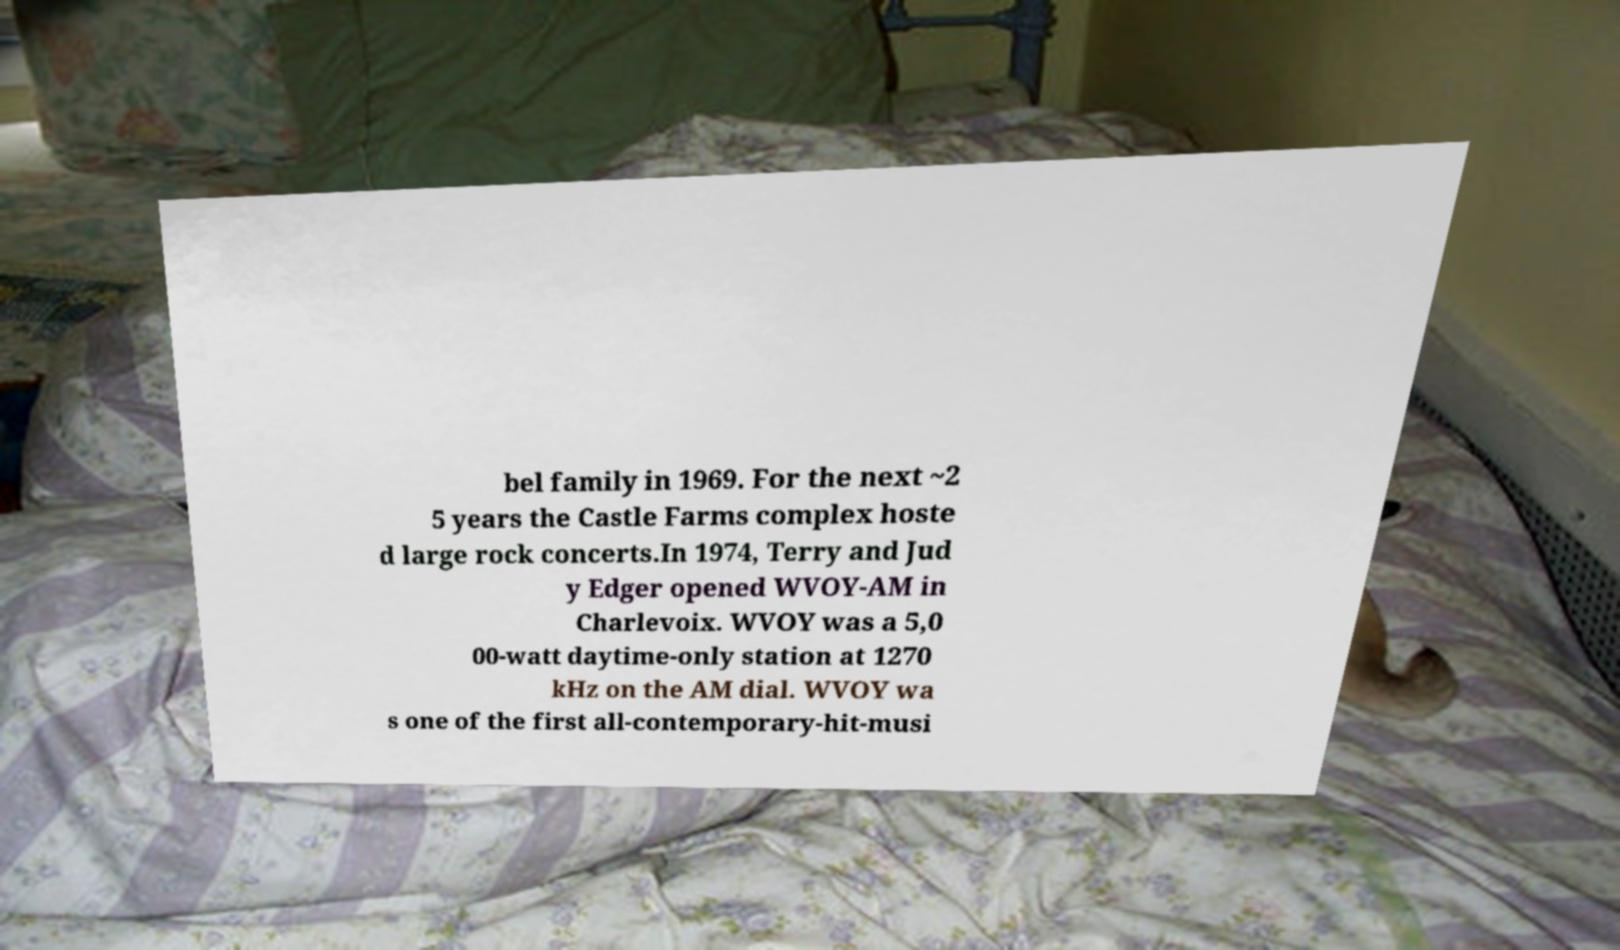What messages or text are displayed in this image? I need them in a readable, typed format. bel family in 1969. For the next ~2 5 years the Castle Farms complex hoste d large rock concerts.In 1974, Terry and Jud y Edger opened WVOY-AM in Charlevoix. WVOY was a 5,0 00-watt daytime-only station at 1270 kHz on the AM dial. WVOY wa s one of the first all-contemporary-hit-musi 